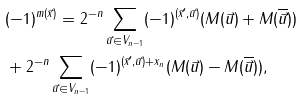<formula> <loc_0><loc_0><loc_500><loc_500>& ( - 1 ) ^ { m ( \vec { x } ) } = 2 ^ { - n } \sum _ { \vec { u } \in V _ { n - 1 } } ( - 1 ) ^ { ( \vec { x } ^ { \prime } , \vec { u } ) } ( M ( \vec { u } ) + M ( \overline { \vec { u } } ) ) \\ & + 2 ^ { - n } \sum _ { \vec { u } \in V _ { n - 1 } } ( - 1 ) ^ { ( \vec { x } ^ { \prime } , \vec { u } ) + x _ { n } } ( M ( \vec { u } ) - M ( \overline { \vec { u } } ) ) ,</formula> 